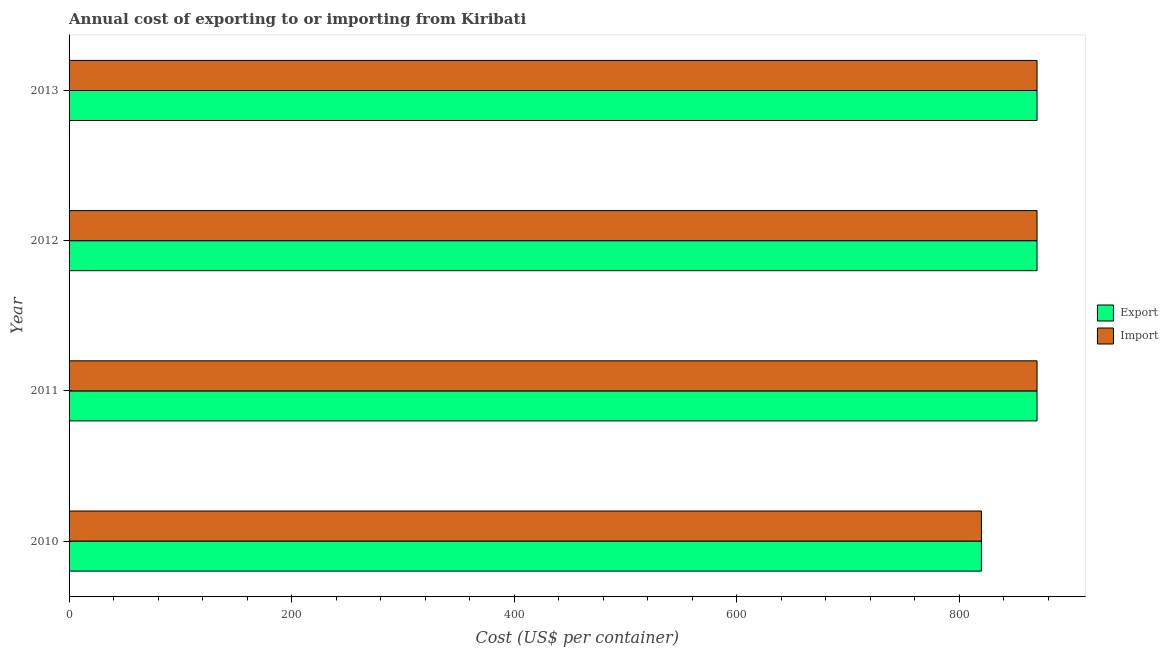How many different coloured bars are there?
Keep it short and to the point. 2. Are the number of bars per tick equal to the number of legend labels?
Make the answer very short. Yes. How many bars are there on the 4th tick from the top?
Your answer should be very brief. 2. How many bars are there on the 3rd tick from the bottom?
Your response must be concise. 2. What is the label of the 2nd group of bars from the top?
Your answer should be compact. 2012. In how many cases, is the number of bars for a given year not equal to the number of legend labels?
Your response must be concise. 0. What is the import cost in 2010?
Give a very brief answer. 820. Across all years, what is the maximum import cost?
Ensure brevity in your answer.  870. Across all years, what is the minimum import cost?
Give a very brief answer. 820. In which year was the export cost minimum?
Keep it short and to the point. 2010. What is the total export cost in the graph?
Give a very brief answer. 3430. What is the difference between the export cost in 2011 and that in 2013?
Provide a short and direct response. 0. What is the average export cost per year?
Your answer should be very brief. 857.5. In how many years, is the export cost greater than 720 US$?
Make the answer very short. 4. Is the export cost in 2011 less than that in 2013?
Your answer should be compact. No. What is the difference between the highest and the lowest export cost?
Your response must be concise. 50. What does the 1st bar from the top in 2010 represents?
Keep it short and to the point. Import. What does the 2nd bar from the bottom in 2013 represents?
Your answer should be compact. Import. How many years are there in the graph?
Make the answer very short. 4. Does the graph contain any zero values?
Make the answer very short. No. How are the legend labels stacked?
Provide a succinct answer. Vertical. What is the title of the graph?
Provide a succinct answer. Annual cost of exporting to or importing from Kiribati. What is the label or title of the X-axis?
Give a very brief answer. Cost (US$ per container). What is the label or title of the Y-axis?
Provide a succinct answer. Year. What is the Cost (US$ per container) in Export in 2010?
Make the answer very short. 820. What is the Cost (US$ per container) in Import in 2010?
Provide a short and direct response. 820. What is the Cost (US$ per container) of Export in 2011?
Provide a short and direct response. 870. What is the Cost (US$ per container) of Import in 2011?
Offer a very short reply. 870. What is the Cost (US$ per container) of Export in 2012?
Your answer should be compact. 870. What is the Cost (US$ per container) in Import in 2012?
Provide a short and direct response. 870. What is the Cost (US$ per container) in Export in 2013?
Give a very brief answer. 870. What is the Cost (US$ per container) in Import in 2013?
Keep it short and to the point. 870. Across all years, what is the maximum Cost (US$ per container) in Export?
Provide a succinct answer. 870. Across all years, what is the maximum Cost (US$ per container) of Import?
Offer a terse response. 870. Across all years, what is the minimum Cost (US$ per container) of Export?
Make the answer very short. 820. Across all years, what is the minimum Cost (US$ per container) in Import?
Ensure brevity in your answer.  820. What is the total Cost (US$ per container) of Export in the graph?
Offer a terse response. 3430. What is the total Cost (US$ per container) of Import in the graph?
Give a very brief answer. 3430. What is the difference between the Cost (US$ per container) in Export in 2010 and that in 2011?
Ensure brevity in your answer.  -50. What is the difference between the Cost (US$ per container) of Import in 2010 and that in 2011?
Offer a very short reply. -50. What is the difference between the Cost (US$ per container) of Export in 2010 and that in 2013?
Your answer should be very brief. -50. What is the difference between the Cost (US$ per container) of Export in 2011 and that in 2013?
Give a very brief answer. 0. What is the difference between the Cost (US$ per container) of Export in 2010 and the Cost (US$ per container) of Import in 2011?
Offer a terse response. -50. What is the difference between the Cost (US$ per container) of Export in 2010 and the Cost (US$ per container) of Import in 2012?
Your answer should be very brief. -50. What is the difference between the Cost (US$ per container) in Export in 2011 and the Cost (US$ per container) in Import in 2012?
Your answer should be compact. 0. What is the difference between the Cost (US$ per container) in Export in 2011 and the Cost (US$ per container) in Import in 2013?
Your answer should be very brief. 0. What is the difference between the Cost (US$ per container) of Export in 2012 and the Cost (US$ per container) of Import in 2013?
Provide a short and direct response. 0. What is the average Cost (US$ per container) of Export per year?
Your response must be concise. 857.5. What is the average Cost (US$ per container) in Import per year?
Offer a very short reply. 857.5. In the year 2011, what is the difference between the Cost (US$ per container) of Export and Cost (US$ per container) of Import?
Keep it short and to the point. 0. In the year 2012, what is the difference between the Cost (US$ per container) of Export and Cost (US$ per container) of Import?
Provide a succinct answer. 0. What is the ratio of the Cost (US$ per container) in Export in 2010 to that in 2011?
Provide a succinct answer. 0.94. What is the ratio of the Cost (US$ per container) in Import in 2010 to that in 2011?
Keep it short and to the point. 0.94. What is the ratio of the Cost (US$ per container) of Export in 2010 to that in 2012?
Offer a terse response. 0.94. What is the ratio of the Cost (US$ per container) of Import in 2010 to that in 2012?
Your response must be concise. 0.94. What is the ratio of the Cost (US$ per container) of Export in 2010 to that in 2013?
Provide a short and direct response. 0.94. What is the ratio of the Cost (US$ per container) of Import in 2010 to that in 2013?
Offer a terse response. 0.94. What is the ratio of the Cost (US$ per container) in Import in 2011 to that in 2012?
Your response must be concise. 1. What is the ratio of the Cost (US$ per container) in Export in 2012 to that in 2013?
Offer a terse response. 1. What is the ratio of the Cost (US$ per container) in Import in 2012 to that in 2013?
Provide a succinct answer. 1. 